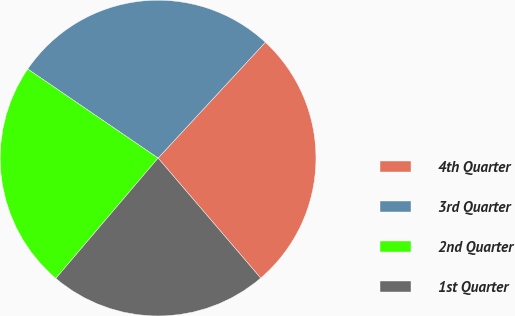Convert chart. <chart><loc_0><loc_0><loc_500><loc_500><pie_chart><fcel>4th Quarter<fcel>3rd Quarter<fcel>2nd Quarter<fcel>1st Quarter<nl><fcel>26.85%<fcel>27.35%<fcel>23.33%<fcel>22.47%<nl></chart> 